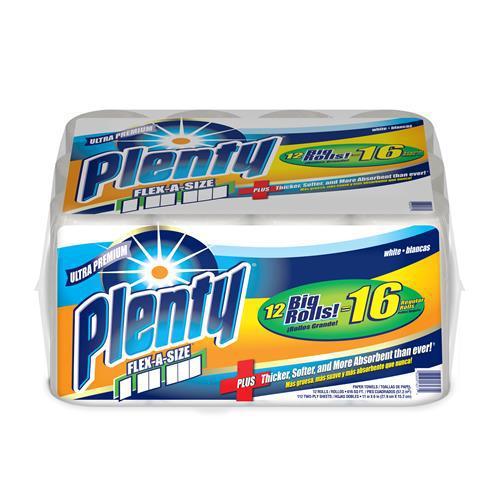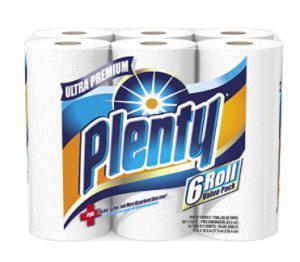The first image is the image on the left, the second image is the image on the right. Analyze the images presented: Is the assertion "Two packages of the same brand of multiple rolls of paper towels are shown, the smaller package with least two rolls, and the larger package at least twice as large as the smaller one." valid? Answer yes or no. Yes. 